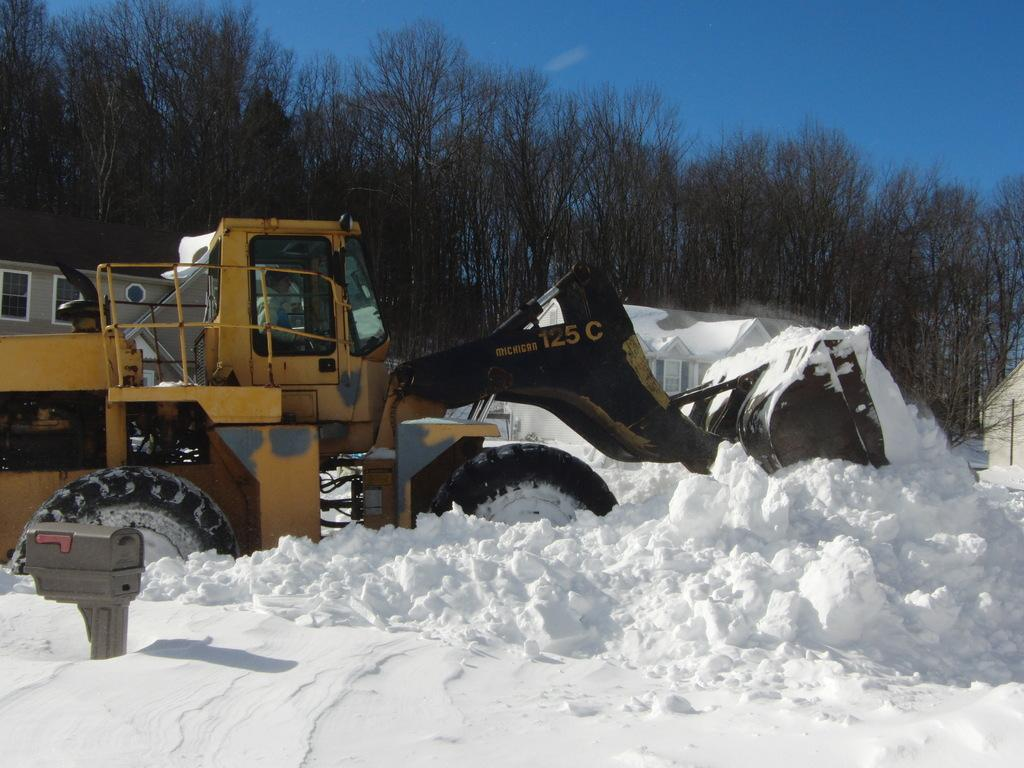What color is the bulldozer in the image? The bulldozer in the image is yellow. Where is the bulldozer located in the image? The bulldozer is on the snow in the image. What type of terrain is visible in the image? There is snow on the land in the image. What structures can be seen in the background of the image? There is a house in the background of the image. What type of vegetation is visible in the background of the image? There are trees visible in the background of the image. What is visible in the sky in the image? The sky is visible in the background of the image. What type of dress is the tramp wearing in the image? There is no tramp or dress present in the image. 